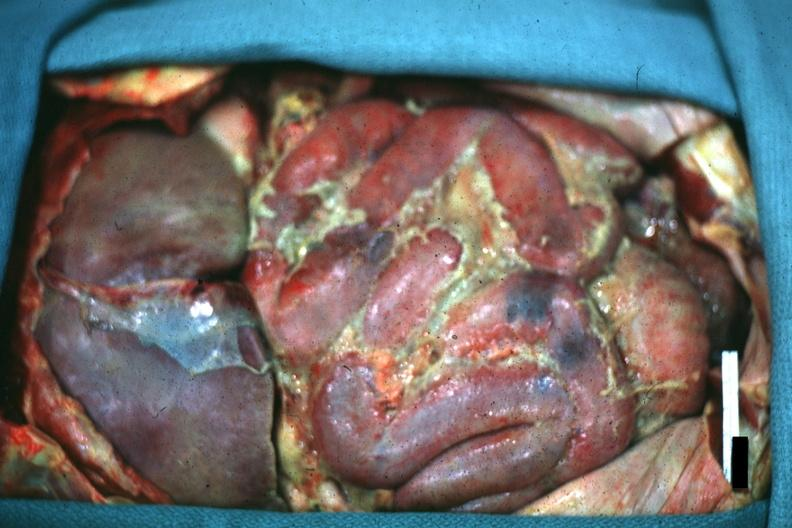what does this image show?
Answer the question using a single word or phrase. Opened peritoneum with fibrinopurulent peritonitis 